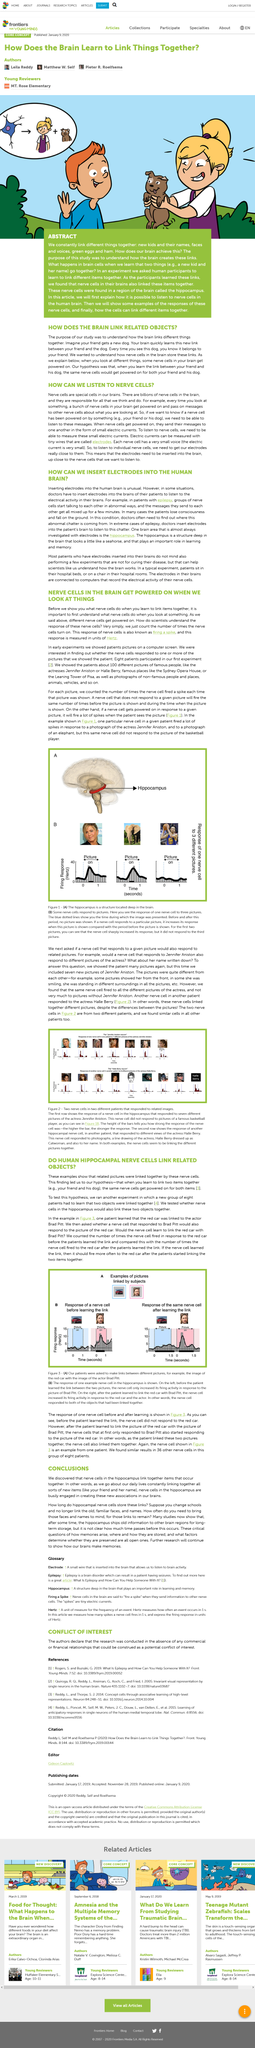Give some essential details in this illustration. In this research study, the actor used was Brad Pitt. The unit of measurement for firing a spike is Hertz. I'm sorry, I'm not sure what you are asking for. Could you please provide more context or clarify your question? The height of the bars represents the strength of the response of the nerve cell, with a higher bar indicating a stronger response. In Part A of Figure 1, the red part is referred to as the hippocampus. 